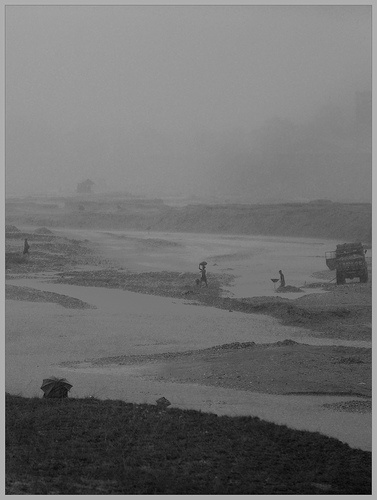Describe the objects in this image and their specific colors. I can see truck in black, gray, and darkgray tones, car in black, gray, and darkgray tones, umbrella in gray, black, and darkgray tones, people in gray, black, and darkgray tones, and people in gray, black, and darkgray tones in this image. 